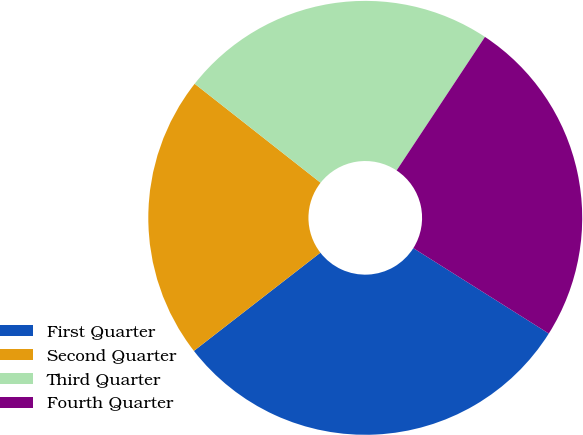Convert chart to OTSL. <chart><loc_0><loc_0><loc_500><loc_500><pie_chart><fcel>First Quarter<fcel>Second Quarter<fcel>Third Quarter<fcel>Fourth Quarter<nl><fcel>30.54%<fcel>21.11%<fcel>23.7%<fcel>24.65%<nl></chart> 